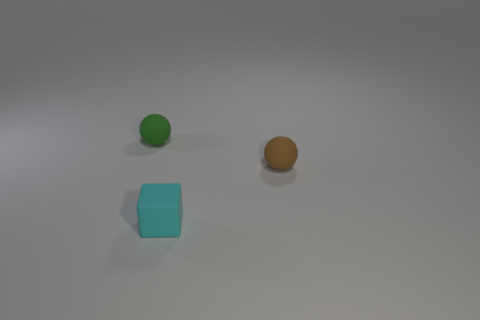What number of large objects are either brown matte things or yellow matte things?
Provide a succinct answer. 0. What is the color of the tiny cube?
Ensure brevity in your answer.  Cyan. What number of brown spheres are in front of the small ball left of the tiny brown rubber thing?
Offer a terse response. 1. There is a matte object that is both in front of the small green object and to the left of the brown sphere; what size is it?
Offer a very short reply. Small. Is there another metallic thing that has the same shape as the small green thing?
Your response must be concise. No. What number of tiny cyan matte objects are the same shape as the green thing?
Offer a terse response. 0. What shape is the object that is behind the tiny brown thing to the right of the cyan matte object?
Give a very brief answer. Sphere. Are there an equal number of matte spheres that are in front of the small brown object and green balls?
Offer a very short reply. No. What is the cyan object that is on the left side of the small rubber ball to the right of the rubber object left of the tiny cyan matte object made of?
Keep it short and to the point. Rubber. Are there any rubber spheres of the same size as the block?
Offer a very short reply. Yes. 